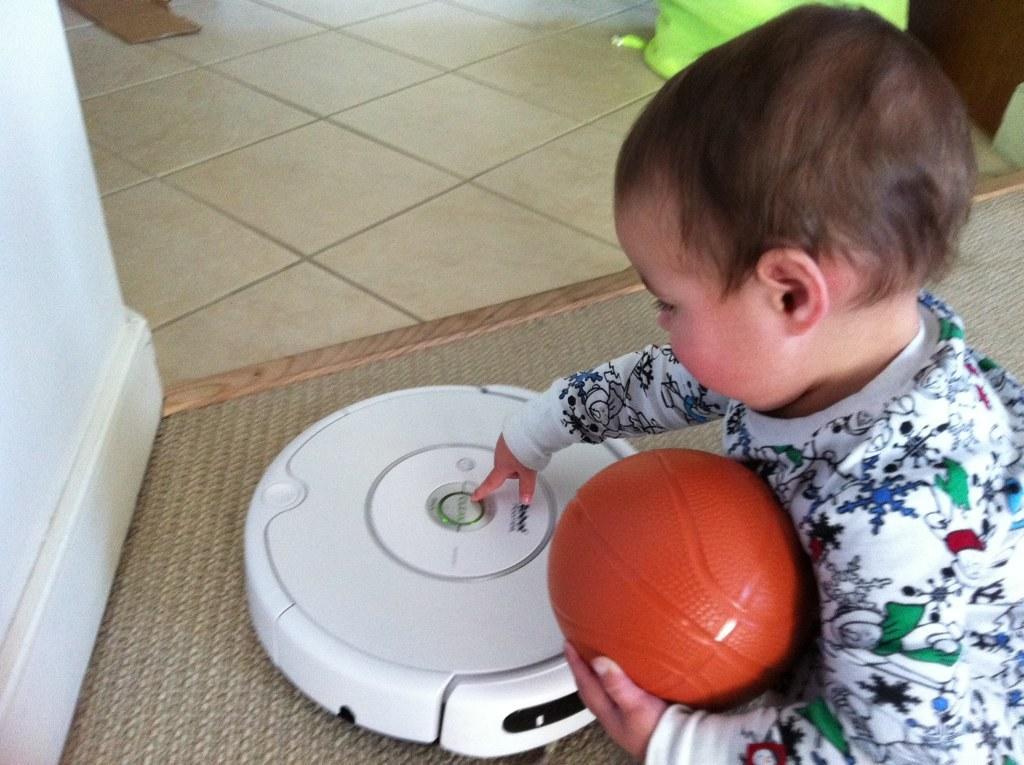Who is present in the image? There is a boy in the image. What is the boy holding? The boy is holding a ball. What is located near the boy? The boy is near a machine. What can be seen in the background of the image? There is a wall in the image. What type of flooring is visible in the image? There is a carpet in the image. What type of lipstick is the boy wearing in the image? The boy is not wearing lipstick in the image; there is no mention of lipstick or any cosmetic products. 